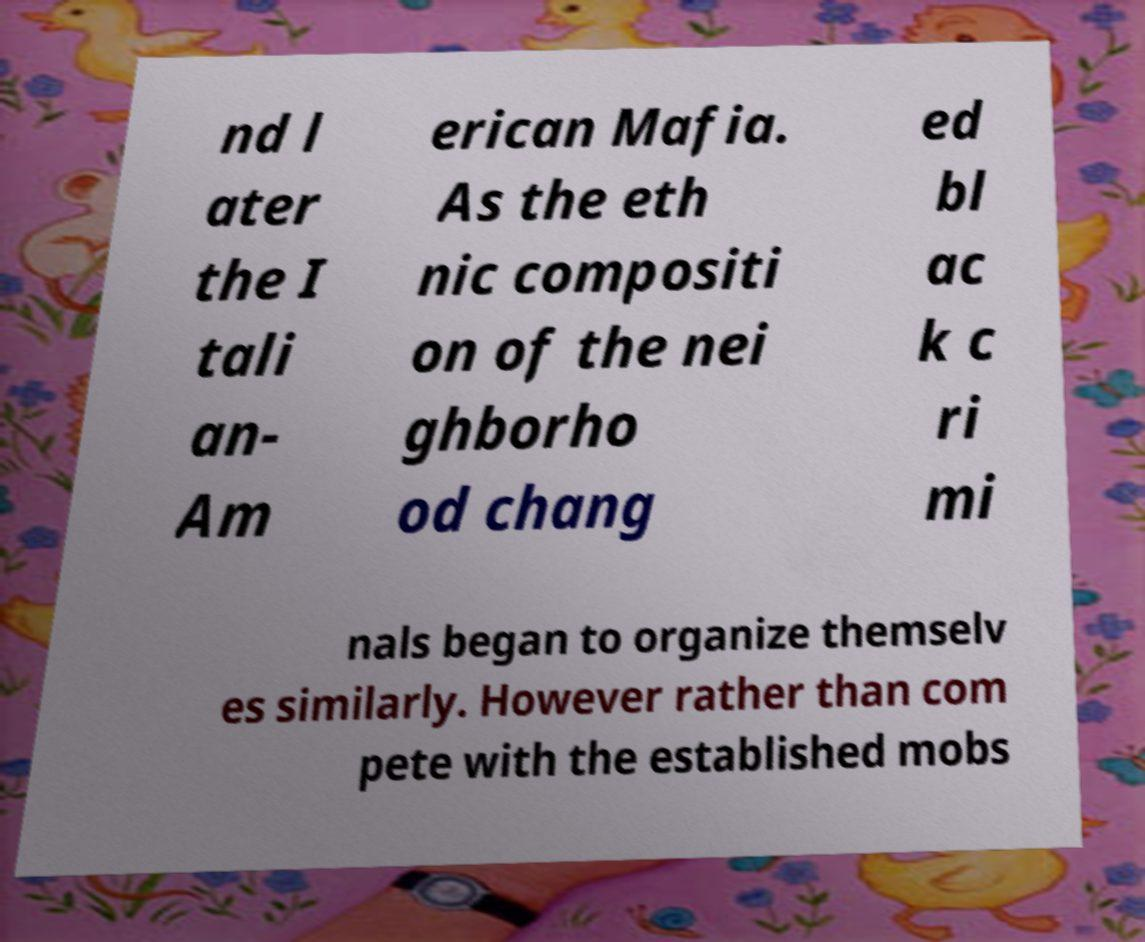For documentation purposes, I need the text within this image transcribed. Could you provide that? nd l ater the I tali an- Am erican Mafia. As the eth nic compositi on of the nei ghborho od chang ed bl ac k c ri mi nals began to organize themselv es similarly. However rather than com pete with the established mobs 